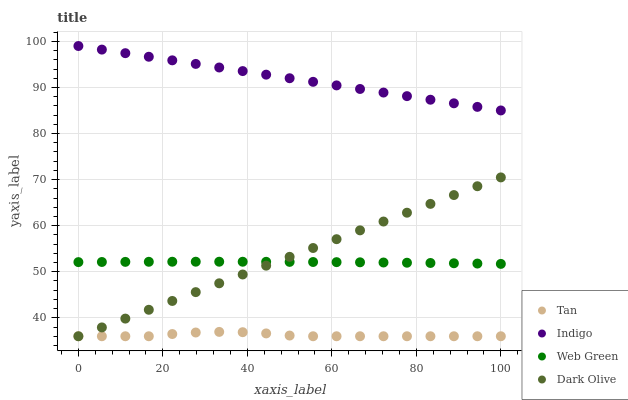Does Tan have the minimum area under the curve?
Answer yes or no. Yes. Does Indigo have the maximum area under the curve?
Answer yes or no. Yes. Does Dark Olive have the minimum area under the curve?
Answer yes or no. No. Does Dark Olive have the maximum area under the curve?
Answer yes or no. No. Is Indigo the smoothest?
Answer yes or no. Yes. Is Tan the roughest?
Answer yes or no. Yes. Is Dark Olive the smoothest?
Answer yes or no. No. Is Dark Olive the roughest?
Answer yes or no. No. Does Tan have the lowest value?
Answer yes or no. Yes. Does Indigo have the lowest value?
Answer yes or no. No. Does Indigo have the highest value?
Answer yes or no. Yes. Does Dark Olive have the highest value?
Answer yes or no. No. Is Tan less than Web Green?
Answer yes or no. Yes. Is Web Green greater than Tan?
Answer yes or no. Yes. Does Web Green intersect Dark Olive?
Answer yes or no. Yes. Is Web Green less than Dark Olive?
Answer yes or no. No. Is Web Green greater than Dark Olive?
Answer yes or no. No. Does Tan intersect Web Green?
Answer yes or no. No. 